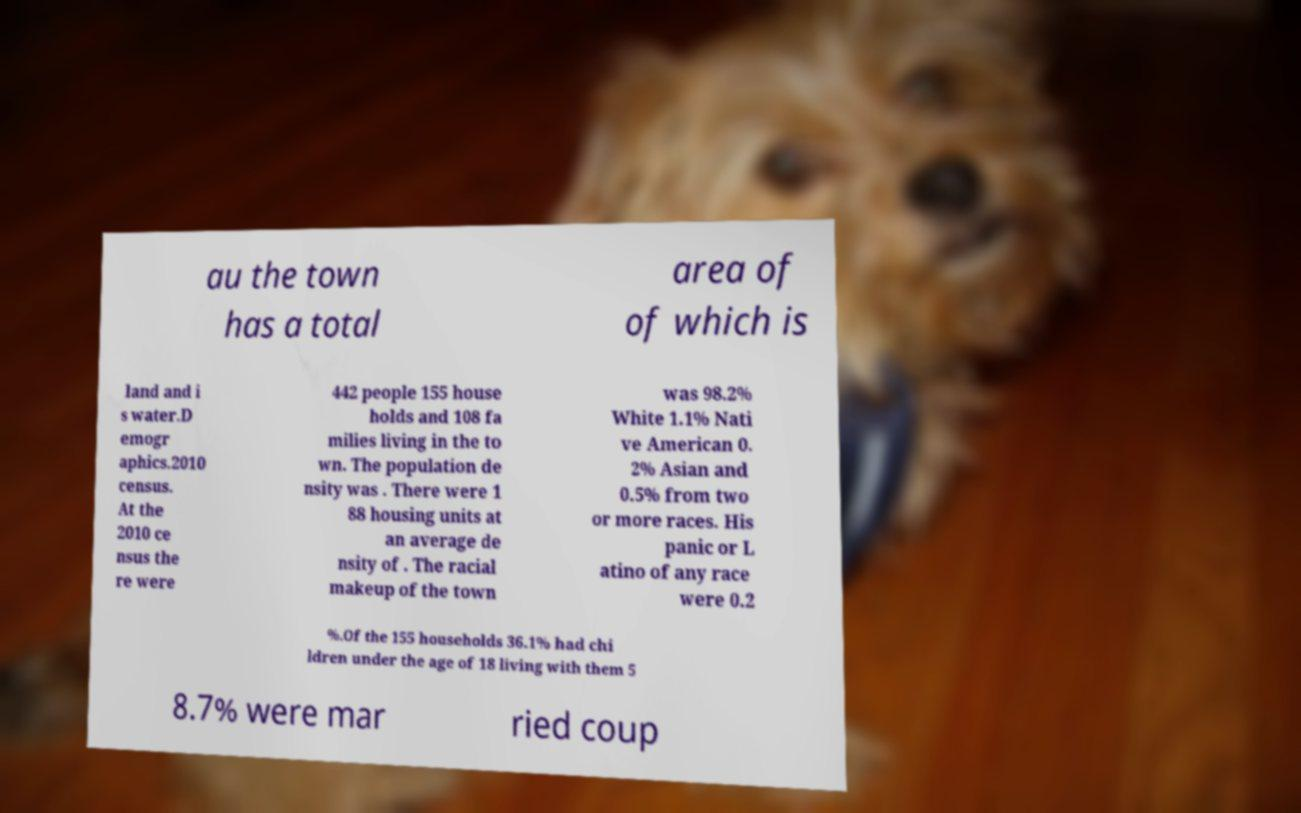What messages or text are displayed in this image? I need them in a readable, typed format. au the town has a total area of of which is land and i s water.D emogr aphics.2010 census. At the 2010 ce nsus the re were 442 people 155 house holds and 108 fa milies living in the to wn. The population de nsity was . There were 1 88 housing units at an average de nsity of . The racial makeup of the town was 98.2% White 1.1% Nati ve American 0. 2% Asian and 0.5% from two or more races. His panic or L atino of any race were 0.2 %.Of the 155 households 36.1% had chi ldren under the age of 18 living with them 5 8.7% were mar ried coup 